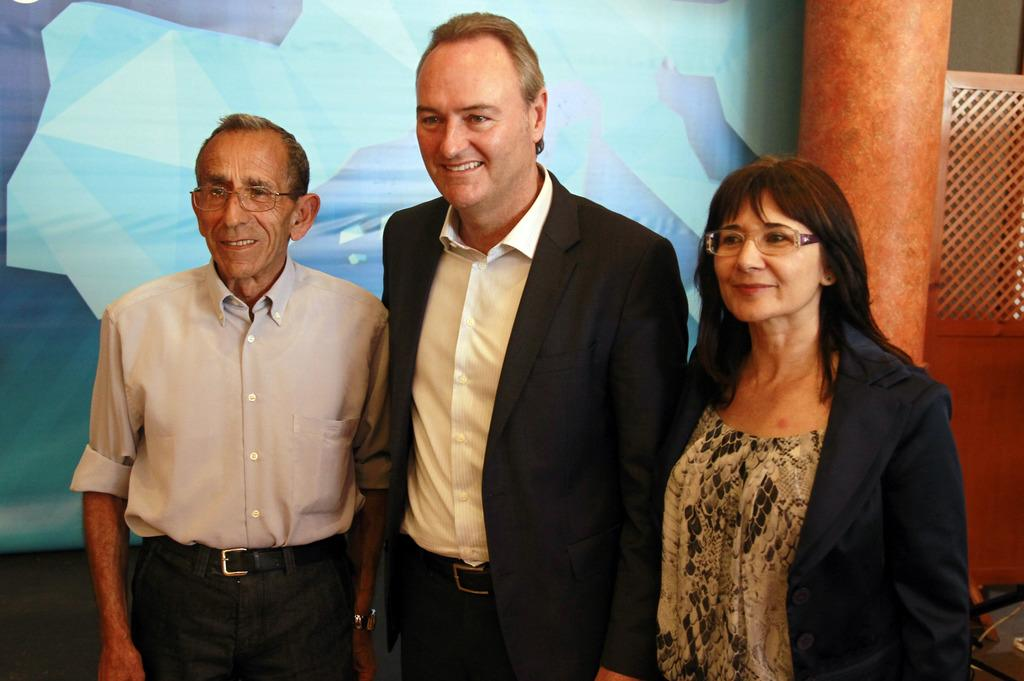How many people are in the image? There are three people standing in the image. What are the people doing in the image? The people are smiling. What can be seen in the background of the image? There is a banner, a pillar, and a wooden object in the background of the image. What type of porter is carrying the wooden object in the image? There is no porter or wooden object being carried in the image. How does the banner blow in the wind in the image? The banner does not blow in the wind in the image; it is stationary. 